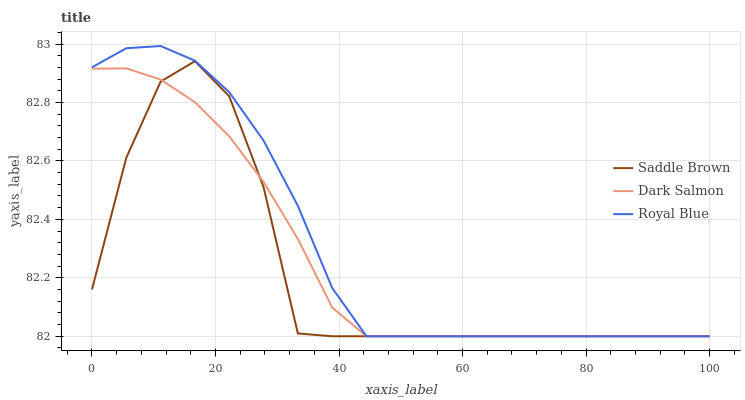Does Saddle Brown have the minimum area under the curve?
Answer yes or no. Yes. Does Royal Blue have the maximum area under the curve?
Answer yes or no. Yes. Does Dark Salmon have the minimum area under the curve?
Answer yes or no. No. Does Dark Salmon have the maximum area under the curve?
Answer yes or no. No. Is Dark Salmon the smoothest?
Answer yes or no. Yes. Is Saddle Brown the roughest?
Answer yes or no. Yes. Is Saddle Brown the smoothest?
Answer yes or no. No. Is Dark Salmon the roughest?
Answer yes or no. No. Does Royal Blue have the lowest value?
Answer yes or no. Yes. Does Royal Blue have the highest value?
Answer yes or no. Yes. Does Saddle Brown have the highest value?
Answer yes or no. No. Does Royal Blue intersect Dark Salmon?
Answer yes or no. Yes. Is Royal Blue less than Dark Salmon?
Answer yes or no. No. Is Royal Blue greater than Dark Salmon?
Answer yes or no. No. 